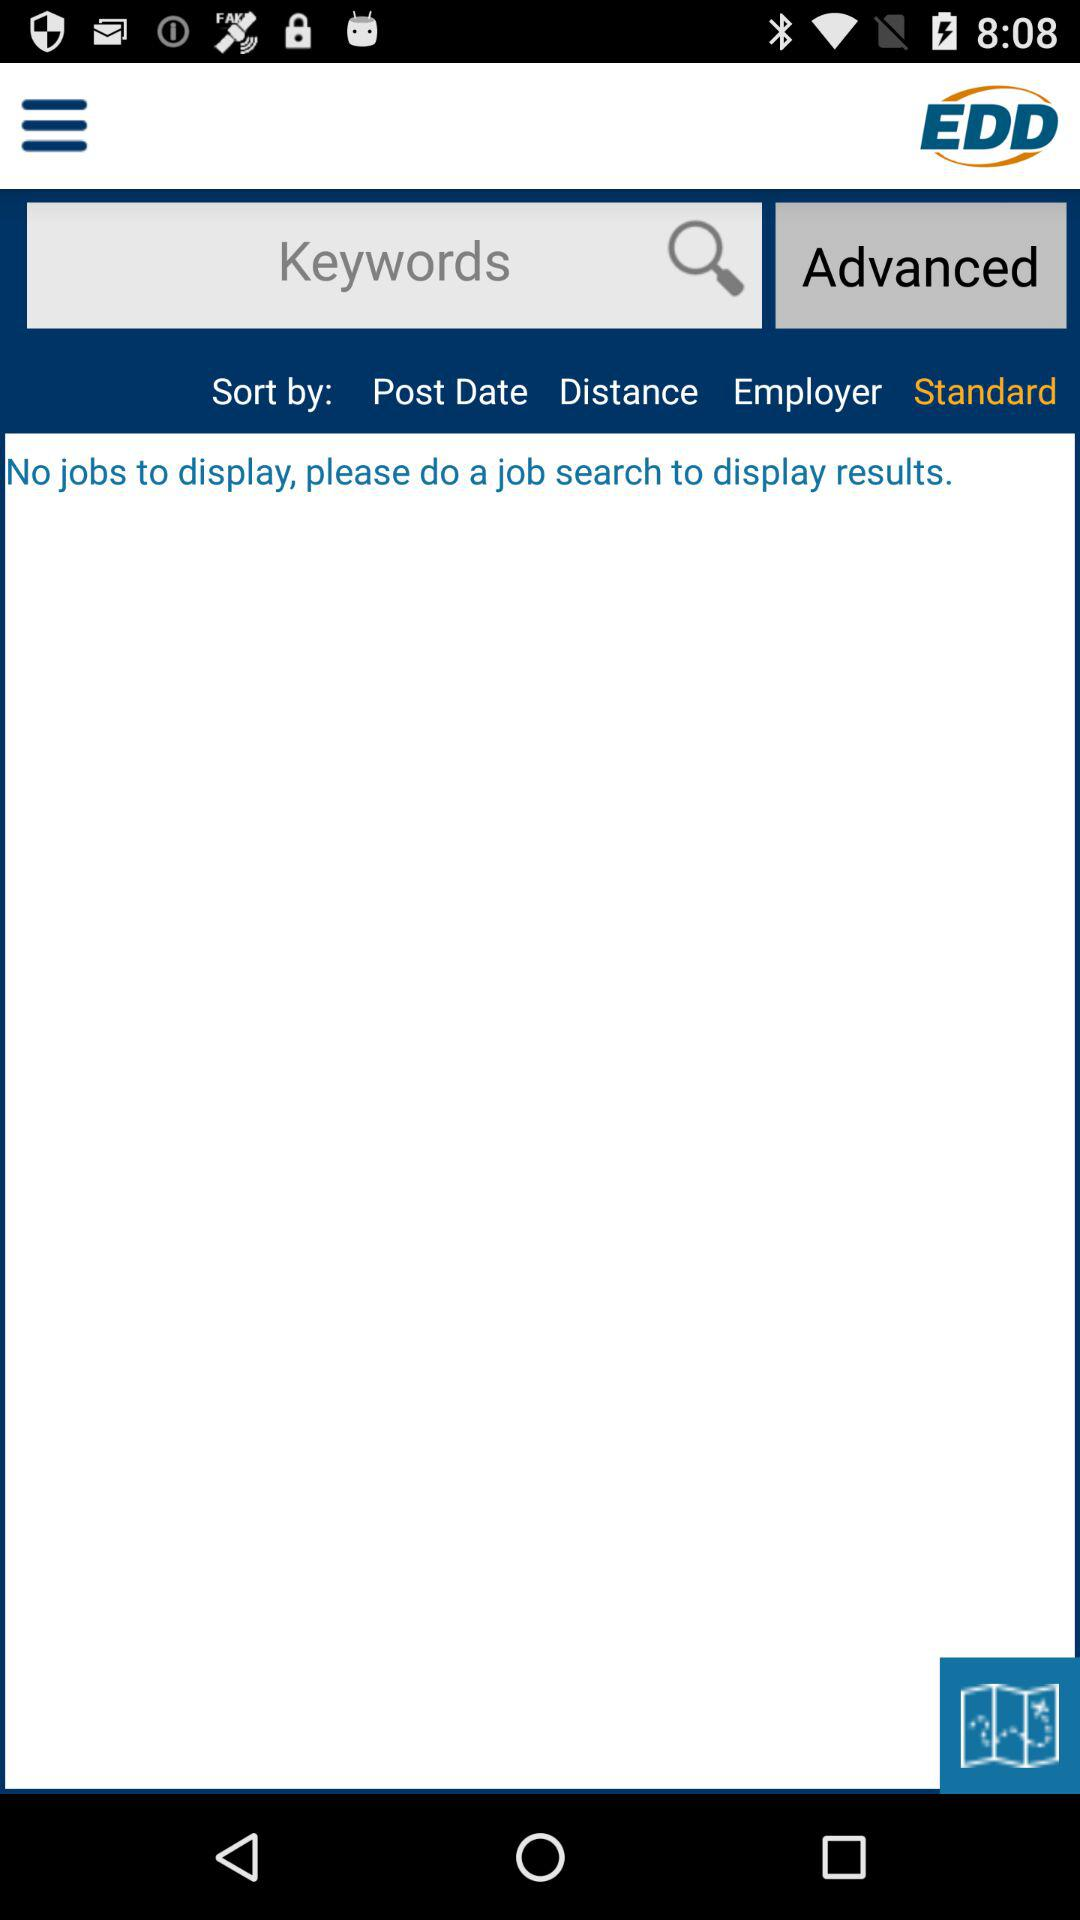What is the name of the application? The name of the application is "EDD". 